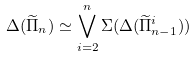Convert formula to latex. <formula><loc_0><loc_0><loc_500><loc_500>\Delta ( \widetilde { \Pi } _ { n } ) \simeq \bigvee _ { i = 2 } ^ { n } \Sigma ( \Delta ( \widetilde { \Pi } _ { n - 1 } ^ { i } ) )</formula> 